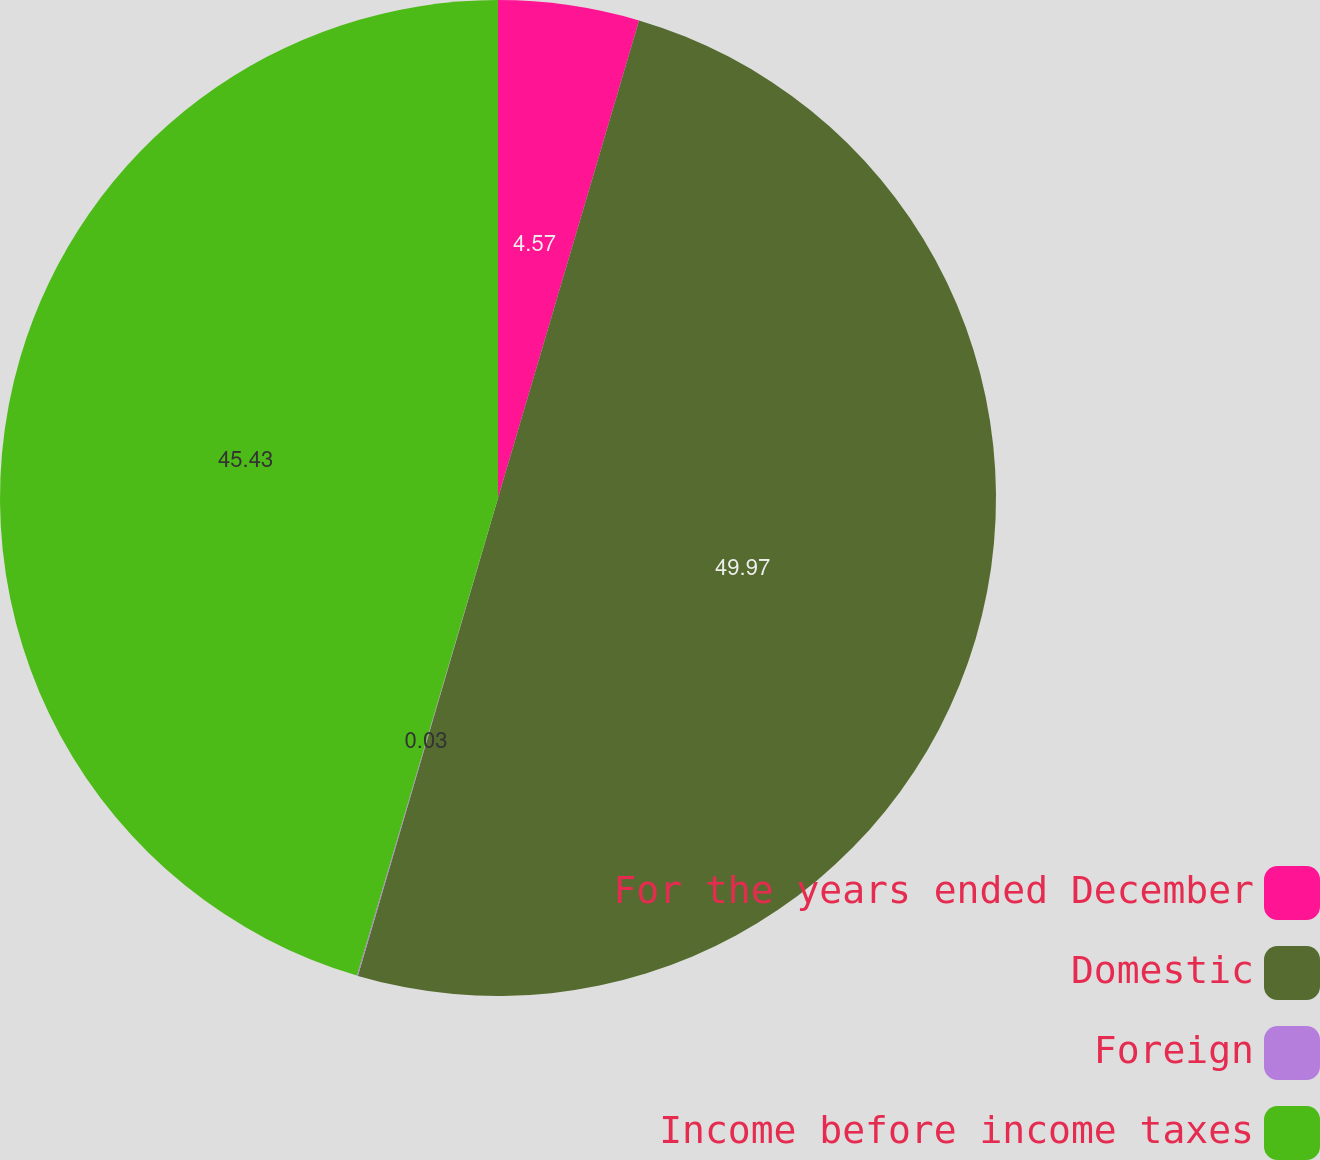Convert chart. <chart><loc_0><loc_0><loc_500><loc_500><pie_chart><fcel>For the years ended December<fcel>Domestic<fcel>Foreign<fcel>Income before income taxes<nl><fcel>4.57%<fcel>49.97%<fcel>0.03%<fcel>45.43%<nl></chart> 